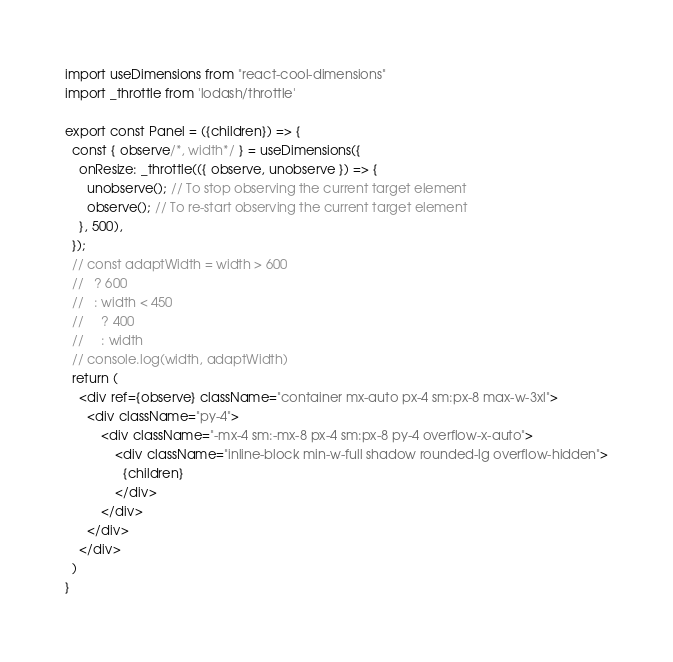<code> <loc_0><loc_0><loc_500><loc_500><_JavaScript_>import useDimensions from "react-cool-dimensions"
import _throttle from 'lodash/throttle'

export const Panel = ({children}) => {
  const { observe/*, width*/ } = useDimensions({
    onResize: _throttle(({ observe, unobserve }) => {
      unobserve(); // To stop observing the current target element
      observe(); // To re-start observing the current target element
    }, 500),
  });
  // const adaptWidth = width > 600
  //   ? 600
  //   : width < 450
  //     ? 400
  //     : width
  // console.log(width, adaptWidth)
  return (
    <div ref={observe} className="container mx-auto px-4 sm:px-8 max-w-3xl">
      <div className="py-4">
          <div className="-mx-4 sm:-mx-8 px-4 sm:px-8 py-4 overflow-x-auto">
              <div className="inline-block min-w-full shadow rounded-lg overflow-hidden">
                {children}
              </div>
          </div>
      </div>
    </div>
  )
}
</code> 